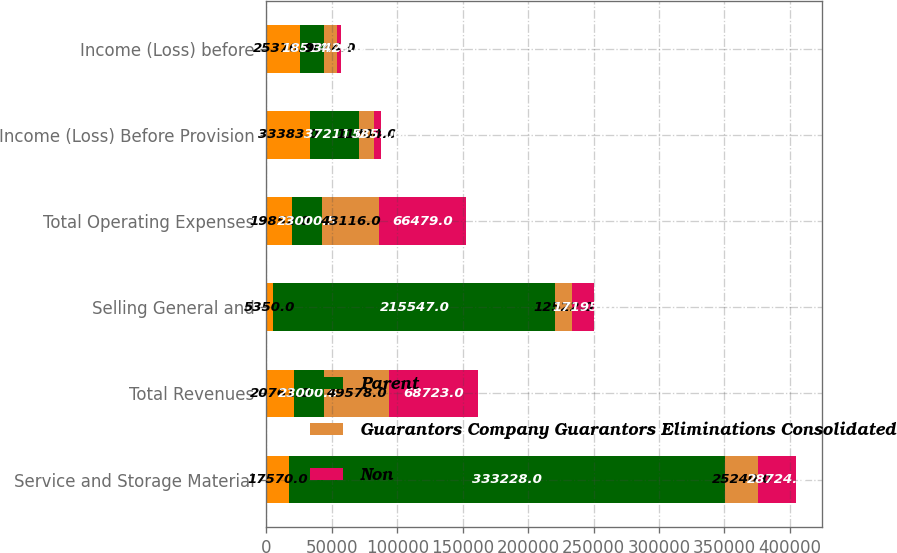<chart> <loc_0><loc_0><loc_500><loc_500><stacked_bar_chart><ecel><fcel>Service and Storage Material<fcel>Total Revenues<fcel>Selling General and<fcel>Total Operating Expenses<fcel>Income (Loss) Before Provision<fcel>Income (Loss) before<nl><fcel>nan<fcel>17570<fcel>20761<fcel>5350<fcel>19852<fcel>33383<fcel>25376<nl><fcel>Parent<fcel>333228<fcel>23000.5<fcel>215547<fcel>23000.5<fcel>37211<fcel>18514<nl><fcel>Guarantors Company Guarantors Eliminations Consolidated<fcel>25240<fcel>49578<fcel>12522<fcel>43116<fcel>11704<fcel>9844<nl><fcel>Non<fcel>28724<fcel>68723<fcel>17195<fcel>66479<fcel>5357<fcel>3428<nl></chart> 